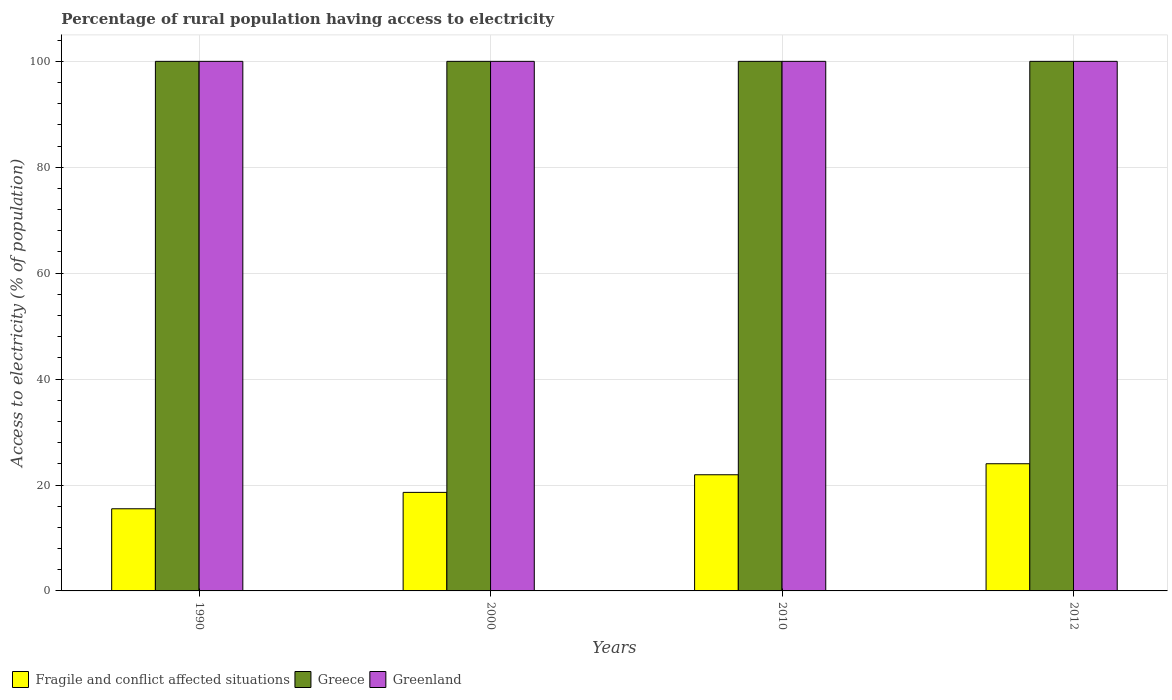How many groups of bars are there?
Your answer should be compact. 4. How many bars are there on the 3rd tick from the right?
Ensure brevity in your answer.  3. In how many cases, is the number of bars for a given year not equal to the number of legend labels?
Offer a very short reply. 0. What is the percentage of rural population having access to electricity in Fragile and conflict affected situations in 2010?
Give a very brief answer. 21.94. Across all years, what is the maximum percentage of rural population having access to electricity in Fragile and conflict affected situations?
Give a very brief answer. 24.01. Across all years, what is the minimum percentage of rural population having access to electricity in Fragile and conflict affected situations?
Offer a terse response. 15.51. What is the total percentage of rural population having access to electricity in Greece in the graph?
Give a very brief answer. 400. What is the difference between the percentage of rural population having access to electricity in Fragile and conflict affected situations in 2000 and that in 2012?
Give a very brief answer. -5.41. What is the average percentage of rural population having access to electricity in Greenland per year?
Provide a short and direct response. 100. In the year 2010, what is the difference between the percentage of rural population having access to electricity in Greenland and percentage of rural population having access to electricity in Greece?
Provide a short and direct response. 0. In how many years, is the percentage of rural population having access to electricity in Fragile and conflict affected situations greater than 40 %?
Give a very brief answer. 0. What is the ratio of the percentage of rural population having access to electricity in Greece in 2010 to that in 2012?
Make the answer very short. 1. What is the difference between the highest and the lowest percentage of rural population having access to electricity in Greenland?
Provide a short and direct response. 0. In how many years, is the percentage of rural population having access to electricity in Greenland greater than the average percentage of rural population having access to electricity in Greenland taken over all years?
Provide a succinct answer. 0. What does the 3rd bar from the left in 1990 represents?
Provide a short and direct response. Greenland. What does the 2nd bar from the right in 2012 represents?
Your answer should be compact. Greece. Is it the case that in every year, the sum of the percentage of rural population having access to electricity in Greece and percentage of rural population having access to electricity in Greenland is greater than the percentage of rural population having access to electricity in Fragile and conflict affected situations?
Your answer should be very brief. Yes. Are all the bars in the graph horizontal?
Offer a very short reply. No. What is the difference between two consecutive major ticks on the Y-axis?
Keep it short and to the point. 20. Are the values on the major ticks of Y-axis written in scientific E-notation?
Offer a very short reply. No. How many legend labels are there?
Provide a short and direct response. 3. How are the legend labels stacked?
Give a very brief answer. Horizontal. What is the title of the graph?
Keep it short and to the point. Percentage of rural population having access to electricity. What is the label or title of the X-axis?
Keep it short and to the point. Years. What is the label or title of the Y-axis?
Give a very brief answer. Access to electricity (% of population). What is the Access to electricity (% of population) of Fragile and conflict affected situations in 1990?
Provide a succinct answer. 15.51. What is the Access to electricity (% of population) of Greece in 1990?
Your answer should be very brief. 100. What is the Access to electricity (% of population) in Fragile and conflict affected situations in 2000?
Keep it short and to the point. 18.61. What is the Access to electricity (% of population) of Greece in 2000?
Your answer should be very brief. 100. What is the Access to electricity (% of population) of Greenland in 2000?
Offer a terse response. 100. What is the Access to electricity (% of population) of Fragile and conflict affected situations in 2010?
Your response must be concise. 21.94. What is the Access to electricity (% of population) of Greece in 2010?
Offer a terse response. 100. What is the Access to electricity (% of population) of Greenland in 2010?
Your answer should be compact. 100. What is the Access to electricity (% of population) of Fragile and conflict affected situations in 2012?
Give a very brief answer. 24.01. Across all years, what is the maximum Access to electricity (% of population) of Fragile and conflict affected situations?
Keep it short and to the point. 24.01. Across all years, what is the maximum Access to electricity (% of population) in Greece?
Provide a short and direct response. 100. Across all years, what is the maximum Access to electricity (% of population) of Greenland?
Offer a terse response. 100. Across all years, what is the minimum Access to electricity (% of population) of Fragile and conflict affected situations?
Give a very brief answer. 15.51. What is the total Access to electricity (% of population) of Fragile and conflict affected situations in the graph?
Provide a succinct answer. 80.07. What is the total Access to electricity (% of population) in Greenland in the graph?
Offer a very short reply. 400. What is the difference between the Access to electricity (% of population) in Fragile and conflict affected situations in 1990 and that in 2000?
Your answer should be very brief. -3.1. What is the difference between the Access to electricity (% of population) in Greece in 1990 and that in 2000?
Give a very brief answer. 0. What is the difference between the Access to electricity (% of population) in Greenland in 1990 and that in 2000?
Provide a short and direct response. 0. What is the difference between the Access to electricity (% of population) of Fragile and conflict affected situations in 1990 and that in 2010?
Offer a terse response. -6.42. What is the difference between the Access to electricity (% of population) in Fragile and conflict affected situations in 1990 and that in 2012?
Your response must be concise. -8.5. What is the difference between the Access to electricity (% of population) of Fragile and conflict affected situations in 2000 and that in 2010?
Your answer should be compact. -3.33. What is the difference between the Access to electricity (% of population) in Greece in 2000 and that in 2010?
Keep it short and to the point. 0. What is the difference between the Access to electricity (% of population) in Greenland in 2000 and that in 2010?
Your response must be concise. 0. What is the difference between the Access to electricity (% of population) of Fragile and conflict affected situations in 2000 and that in 2012?
Keep it short and to the point. -5.41. What is the difference between the Access to electricity (% of population) in Greece in 2000 and that in 2012?
Provide a succinct answer. 0. What is the difference between the Access to electricity (% of population) of Fragile and conflict affected situations in 2010 and that in 2012?
Your response must be concise. -2.08. What is the difference between the Access to electricity (% of population) of Greenland in 2010 and that in 2012?
Make the answer very short. 0. What is the difference between the Access to electricity (% of population) of Fragile and conflict affected situations in 1990 and the Access to electricity (% of population) of Greece in 2000?
Provide a short and direct response. -84.49. What is the difference between the Access to electricity (% of population) in Fragile and conflict affected situations in 1990 and the Access to electricity (% of population) in Greenland in 2000?
Offer a very short reply. -84.49. What is the difference between the Access to electricity (% of population) of Greece in 1990 and the Access to electricity (% of population) of Greenland in 2000?
Make the answer very short. 0. What is the difference between the Access to electricity (% of population) in Fragile and conflict affected situations in 1990 and the Access to electricity (% of population) in Greece in 2010?
Your answer should be compact. -84.49. What is the difference between the Access to electricity (% of population) of Fragile and conflict affected situations in 1990 and the Access to electricity (% of population) of Greenland in 2010?
Offer a terse response. -84.49. What is the difference between the Access to electricity (% of population) in Greece in 1990 and the Access to electricity (% of population) in Greenland in 2010?
Ensure brevity in your answer.  0. What is the difference between the Access to electricity (% of population) of Fragile and conflict affected situations in 1990 and the Access to electricity (% of population) of Greece in 2012?
Make the answer very short. -84.49. What is the difference between the Access to electricity (% of population) in Fragile and conflict affected situations in 1990 and the Access to electricity (% of population) in Greenland in 2012?
Provide a short and direct response. -84.49. What is the difference between the Access to electricity (% of population) in Greece in 1990 and the Access to electricity (% of population) in Greenland in 2012?
Make the answer very short. 0. What is the difference between the Access to electricity (% of population) in Fragile and conflict affected situations in 2000 and the Access to electricity (% of population) in Greece in 2010?
Provide a succinct answer. -81.39. What is the difference between the Access to electricity (% of population) in Fragile and conflict affected situations in 2000 and the Access to electricity (% of population) in Greenland in 2010?
Your response must be concise. -81.39. What is the difference between the Access to electricity (% of population) in Fragile and conflict affected situations in 2000 and the Access to electricity (% of population) in Greece in 2012?
Your response must be concise. -81.39. What is the difference between the Access to electricity (% of population) of Fragile and conflict affected situations in 2000 and the Access to electricity (% of population) of Greenland in 2012?
Make the answer very short. -81.39. What is the difference between the Access to electricity (% of population) of Fragile and conflict affected situations in 2010 and the Access to electricity (% of population) of Greece in 2012?
Ensure brevity in your answer.  -78.06. What is the difference between the Access to electricity (% of population) in Fragile and conflict affected situations in 2010 and the Access to electricity (% of population) in Greenland in 2012?
Your answer should be very brief. -78.06. What is the average Access to electricity (% of population) in Fragile and conflict affected situations per year?
Offer a very short reply. 20.02. What is the average Access to electricity (% of population) of Greece per year?
Make the answer very short. 100. In the year 1990, what is the difference between the Access to electricity (% of population) of Fragile and conflict affected situations and Access to electricity (% of population) of Greece?
Provide a short and direct response. -84.49. In the year 1990, what is the difference between the Access to electricity (% of population) of Fragile and conflict affected situations and Access to electricity (% of population) of Greenland?
Make the answer very short. -84.49. In the year 2000, what is the difference between the Access to electricity (% of population) of Fragile and conflict affected situations and Access to electricity (% of population) of Greece?
Your answer should be very brief. -81.39. In the year 2000, what is the difference between the Access to electricity (% of population) of Fragile and conflict affected situations and Access to electricity (% of population) of Greenland?
Your answer should be very brief. -81.39. In the year 2000, what is the difference between the Access to electricity (% of population) in Greece and Access to electricity (% of population) in Greenland?
Provide a succinct answer. 0. In the year 2010, what is the difference between the Access to electricity (% of population) of Fragile and conflict affected situations and Access to electricity (% of population) of Greece?
Provide a short and direct response. -78.06. In the year 2010, what is the difference between the Access to electricity (% of population) of Fragile and conflict affected situations and Access to electricity (% of population) of Greenland?
Ensure brevity in your answer.  -78.06. In the year 2012, what is the difference between the Access to electricity (% of population) in Fragile and conflict affected situations and Access to electricity (% of population) in Greece?
Your answer should be very brief. -75.99. In the year 2012, what is the difference between the Access to electricity (% of population) in Fragile and conflict affected situations and Access to electricity (% of population) in Greenland?
Make the answer very short. -75.99. In the year 2012, what is the difference between the Access to electricity (% of population) in Greece and Access to electricity (% of population) in Greenland?
Ensure brevity in your answer.  0. What is the ratio of the Access to electricity (% of population) of Fragile and conflict affected situations in 1990 to that in 2000?
Keep it short and to the point. 0.83. What is the ratio of the Access to electricity (% of population) in Fragile and conflict affected situations in 1990 to that in 2010?
Make the answer very short. 0.71. What is the ratio of the Access to electricity (% of population) of Greece in 1990 to that in 2010?
Offer a very short reply. 1. What is the ratio of the Access to electricity (% of population) in Greenland in 1990 to that in 2010?
Offer a terse response. 1. What is the ratio of the Access to electricity (% of population) of Fragile and conflict affected situations in 1990 to that in 2012?
Provide a short and direct response. 0.65. What is the ratio of the Access to electricity (% of population) of Fragile and conflict affected situations in 2000 to that in 2010?
Provide a succinct answer. 0.85. What is the ratio of the Access to electricity (% of population) in Greece in 2000 to that in 2010?
Your answer should be compact. 1. What is the ratio of the Access to electricity (% of population) in Greenland in 2000 to that in 2010?
Keep it short and to the point. 1. What is the ratio of the Access to electricity (% of population) in Fragile and conflict affected situations in 2000 to that in 2012?
Your answer should be compact. 0.77. What is the ratio of the Access to electricity (% of population) of Fragile and conflict affected situations in 2010 to that in 2012?
Provide a succinct answer. 0.91. What is the ratio of the Access to electricity (% of population) of Greenland in 2010 to that in 2012?
Your response must be concise. 1. What is the difference between the highest and the second highest Access to electricity (% of population) in Fragile and conflict affected situations?
Provide a succinct answer. 2.08. What is the difference between the highest and the second highest Access to electricity (% of population) in Greece?
Your answer should be compact. 0. What is the difference between the highest and the lowest Access to electricity (% of population) in Fragile and conflict affected situations?
Keep it short and to the point. 8.5. 